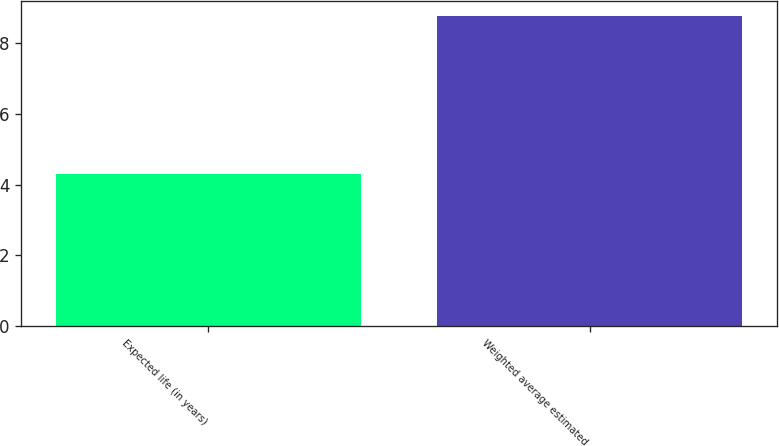<chart> <loc_0><loc_0><loc_500><loc_500><bar_chart><fcel>Expected life (in years)<fcel>Weighted average estimated<nl><fcel>4.3<fcel>8.77<nl></chart> 